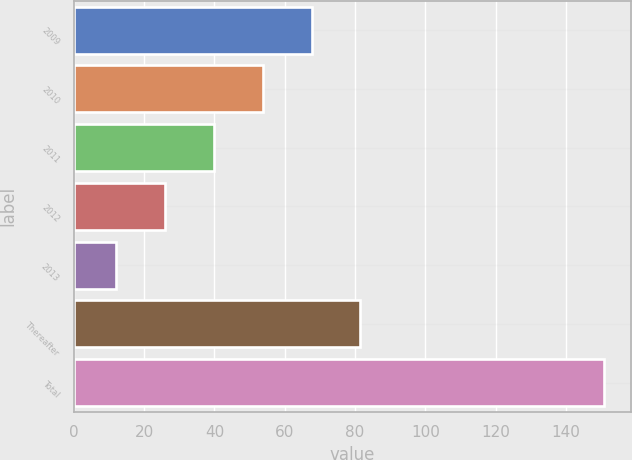Convert chart. <chart><loc_0><loc_0><loc_500><loc_500><bar_chart><fcel>2009<fcel>2010<fcel>2011<fcel>2012<fcel>2013<fcel>Thereafter<fcel>Total<nl><fcel>67.66<fcel>53.77<fcel>39.88<fcel>25.99<fcel>12.1<fcel>81.55<fcel>151<nl></chart> 